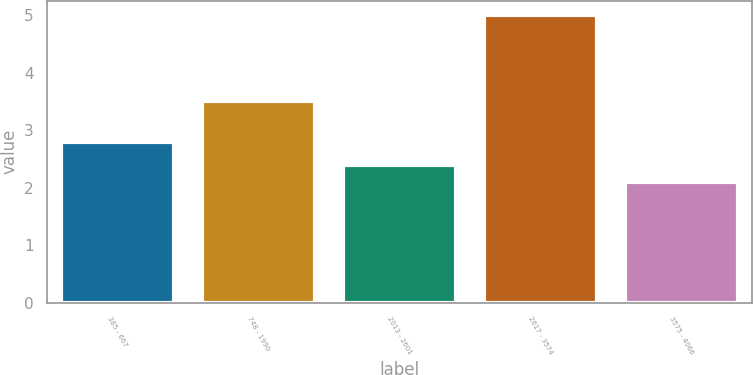Convert chart to OTSL. <chart><loc_0><loc_0><loc_500><loc_500><bar_chart><fcel>385 - 667<fcel>748 - 1990<fcel>2013 - 2601<fcel>2617 - 3574<fcel>3575 - 4066<nl><fcel>2.8<fcel>3.5<fcel>2.4<fcel>5<fcel>2.1<nl></chart> 